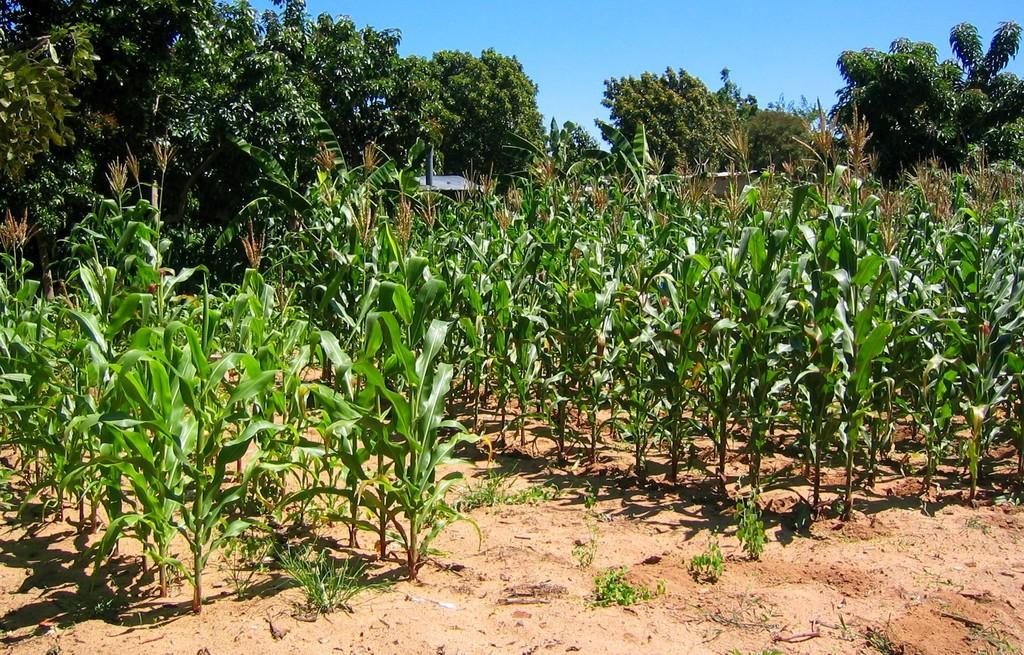What type of vegetation can be seen in the image? There are trees and small plants in the image. What color are the trees and plants in the image? The trees and plants are green in color. What color is the sky in the image? The sky is blue in color. What type of terrain is visible in the image? There is mud visible in the image. What type of advertisement can be seen on the trees in the image? There are no advertisements present on the trees in the image. What type of attraction is visible in the image? There is no attraction visible in the image; it features trees, small plants, and mud. 